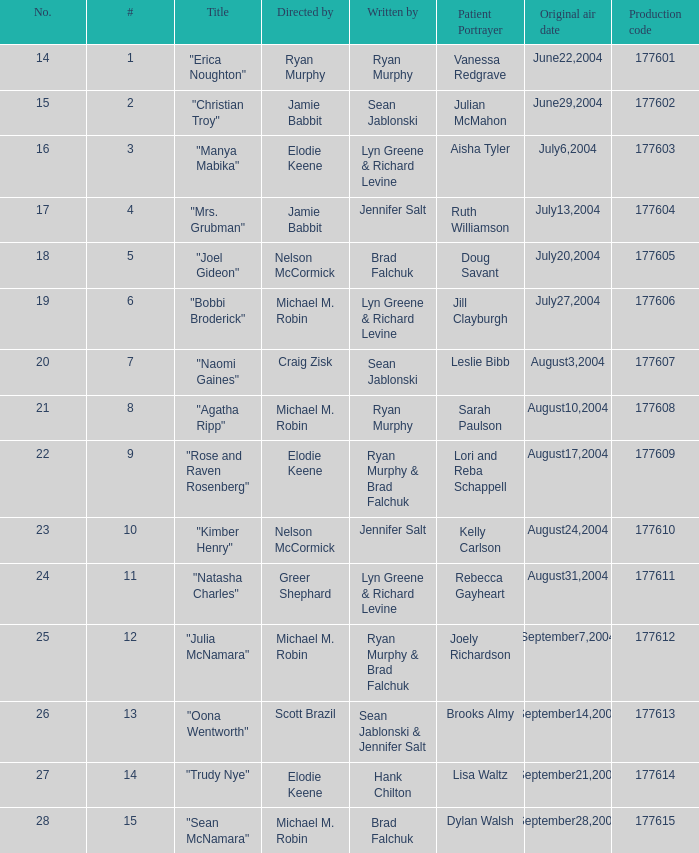How many episodes are numbered 4 in the season? 1.0. 